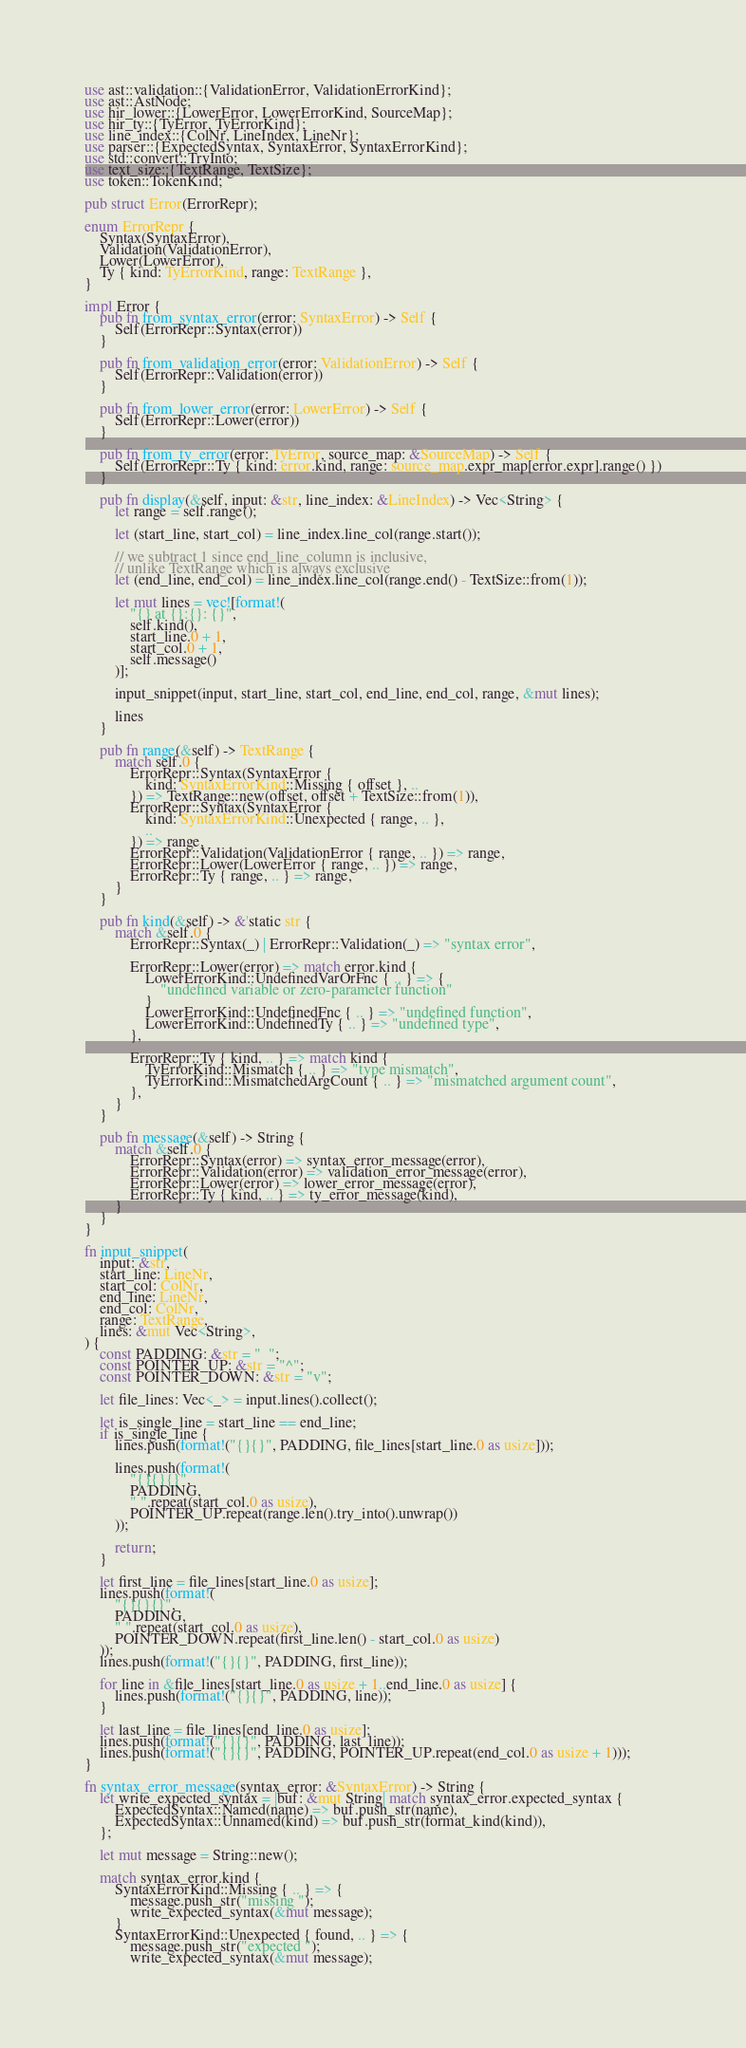Convert code to text. <code><loc_0><loc_0><loc_500><loc_500><_Rust_>use ast::validation::{ValidationError, ValidationErrorKind};
use ast::AstNode;
use hir_lower::{LowerError, LowerErrorKind, SourceMap};
use hir_ty::{TyError, TyErrorKind};
use line_index::{ColNr, LineIndex, LineNr};
use parser::{ExpectedSyntax, SyntaxError, SyntaxErrorKind};
use std::convert::TryInto;
use text_size::{TextRange, TextSize};
use token::TokenKind;

pub struct Error(ErrorRepr);

enum ErrorRepr {
    Syntax(SyntaxError),
    Validation(ValidationError),
    Lower(LowerError),
    Ty { kind: TyErrorKind, range: TextRange },
}

impl Error {
    pub fn from_syntax_error(error: SyntaxError) -> Self {
        Self(ErrorRepr::Syntax(error))
    }

    pub fn from_validation_error(error: ValidationError) -> Self {
        Self(ErrorRepr::Validation(error))
    }

    pub fn from_lower_error(error: LowerError) -> Self {
        Self(ErrorRepr::Lower(error))
    }

    pub fn from_ty_error(error: TyError, source_map: &SourceMap) -> Self {
        Self(ErrorRepr::Ty { kind: error.kind, range: source_map.expr_map[error.expr].range() })
    }

    pub fn display(&self, input: &str, line_index: &LineIndex) -> Vec<String> {
        let range = self.range();

        let (start_line, start_col) = line_index.line_col(range.start());

        // we subtract 1 since end_line_column is inclusive,
        // unlike TextRange which is always exclusive
        let (end_line, end_col) = line_index.line_col(range.end() - TextSize::from(1));

        let mut lines = vec![format!(
            "{} at {}:{}: {}",
            self.kind(),
            start_line.0 + 1,
            start_col.0 + 1,
            self.message()
        )];

        input_snippet(input, start_line, start_col, end_line, end_col, range, &mut lines);

        lines
    }

    pub fn range(&self) -> TextRange {
        match self.0 {
            ErrorRepr::Syntax(SyntaxError {
                kind: SyntaxErrorKind::Missing { offset }, ..
            }) => TextRange::new(offset, offset + TextSize::from(1)),
            ErrorRepr::Syntax(SyntaxError {
                kind: SyntaxErrorKind::Unexpected { range, .. },
                ..
            }) => range,
            ErrorRepr::Validation(ValidationError { range, .. }) => range,
            ErrorRepr::Lower(LowerError { range, .. }) => range,
            ErrorRepr::Ty { range, .. } => range,
        }
    }

    pub fn kind(&self) -> &'static str {
        match &self.0 {
            ErrorRepr::Syntax(_) | ErrorRepr::Validation(_) => "syntax error",

            ErrorRepr::Lower(error) => match error.kind {
                LowerErrorKind::UndefinedVarOrFnc { .. } => {
                    "undefined variable or zero-parameter function"
                }
                LowerErrorKind::UndefinedFnc { .. } => "undefined function",
                LowerErrorKind::UndefinedTy { .. } => "undefined type",
            },

            ErrorRepr::Ty { kind, .. } => match kind {
                TyErrorKind::Mismatch { .. } => "type mismatch",
                TyErrorKind::MismatchedArgCount { .. } => "mismatched argument count",
            },
        }
    }

    pub fn message(&self) -> String {
        match &self.0 {
            ErrorRepr::Syntax(error) => syntax_error_message(error),
            ErrorRepr::Validation(error) => validation_error_message(error),
            ErrorRepr::Lower(error) => lower_error_message(error),
            ErrorRepr::Ty { kind, .. } => ty_error_message(kind),
        }
    }
}

fn input_snippet(
    input: &str,
    start_line: LineNr,
    start_col: ColNr,
    end_line: LineNr,
    end_col: ColNr,
    range: TextRange,
    lines: &mut Vec<String>,
) {
    const PADDING: &str = "  ";
    const POINTER_UP: &str = "^";
    const POINTER_DOWN: &str = "v";

    let file_lines: Vec<_> = input.lines().collect();

    let is_single_line = start_line == end_line;
    if is_single_line {
        lines.push(format!("{}{}", PADDING, file_lines[start_line.0 as usize]));

        lines.push(format!(
            "{}{}{}",
            PADDING,
            " ".repeat(start_col.0 as usize),
            POINTER_UP.repeat(range.len().try_into().unwrap())
        ));

        return;
    }

    let first_line = file_lines[start_line.0 as usize];
    lines.push(format!(
        "{}{}{}",
        PADDING,
        " ".repeat(start_col.0 as usize),
        POINTER_DOWN.repeat(first_line.len() - start_col.0 as usize)
    ));
    lines.push(format!("{}{}", PADDING, first_line));

    for line in &file_lines[start_line.0 as usize + 1..end_line.0 as usize] {
        lines.push(format!("{}{}", PADDING, line));
    }

    let last_line = file_lines[end_line.0 as usize];
    lines.push(format!("{}{}", PADDING, last_line));
    lines.push(format!("{}{}", PADDING, POINTER_UP.repeat(end_col.0 as usize + 1)));
}

fn syntax_error_message(syntax_error: &SyntaxError) -> String {
    let write_expected_syntax = |buf: &mut String| match syntax_error.expected_syntax {
        ExpectedSyntax::Named(name) => buf.push_str(name),
        ExpectedSyntax::Unnamed(kind) => buf.push_str(format_kind(kind)),
    };

    let mut message = String::new();

    match syntax_error.kind {
        SyntaxErrorKind::Missing { .. } => {
            message.push_str("missing ");
            write_expected_syntax(&mut message);
        }
        SyntaxErrorKind::Unexpected { found, .. } => {
            message.push_str("expected ");
            write_expected_syntax(&mut message);</code> 